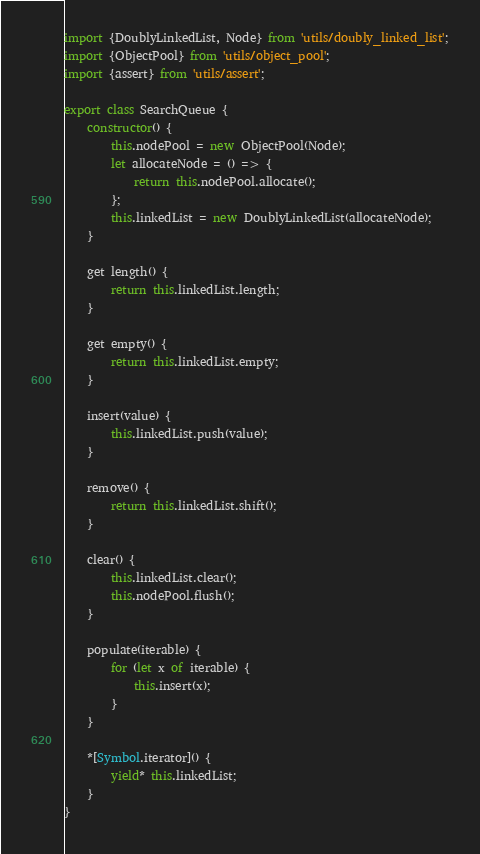<code> <loc_0><loc_0><loc_500><loc_500><_JavaScript_>import {DoublyLinkedList, Node} from 'utils/doubly_linked_list';
import {ObjectPool} from 'utils/object_pool';
import {assert} from 'utils/assert';

export class SearchQueue {
    constructor() {
        this.nodePool = new ObjectPool(Node);
        let allocateNode = () => {
            return this.nodePool.allocate();
        };
        this.linkedList = new DoublyLinkedList(allocateNode);
    }

    get length() {
        return this.linkedList.length;
    }

    get empty() {
        return this.linkedList.empty;
    }

    insert(value) {
        this.linkedList.push(value);
    }

    remove() {
        return this.linkedList.shift();
    }

    clear() {
        this.linkedList.clear();
        this.nodePool.flush();
    }

    populate(iterable) {
        for (let x of iterable) {
            this.insert(x);
        }
    }

    *[Symbol.iterator]() {
        yield* this.linkedList;
    }
}
</code> 